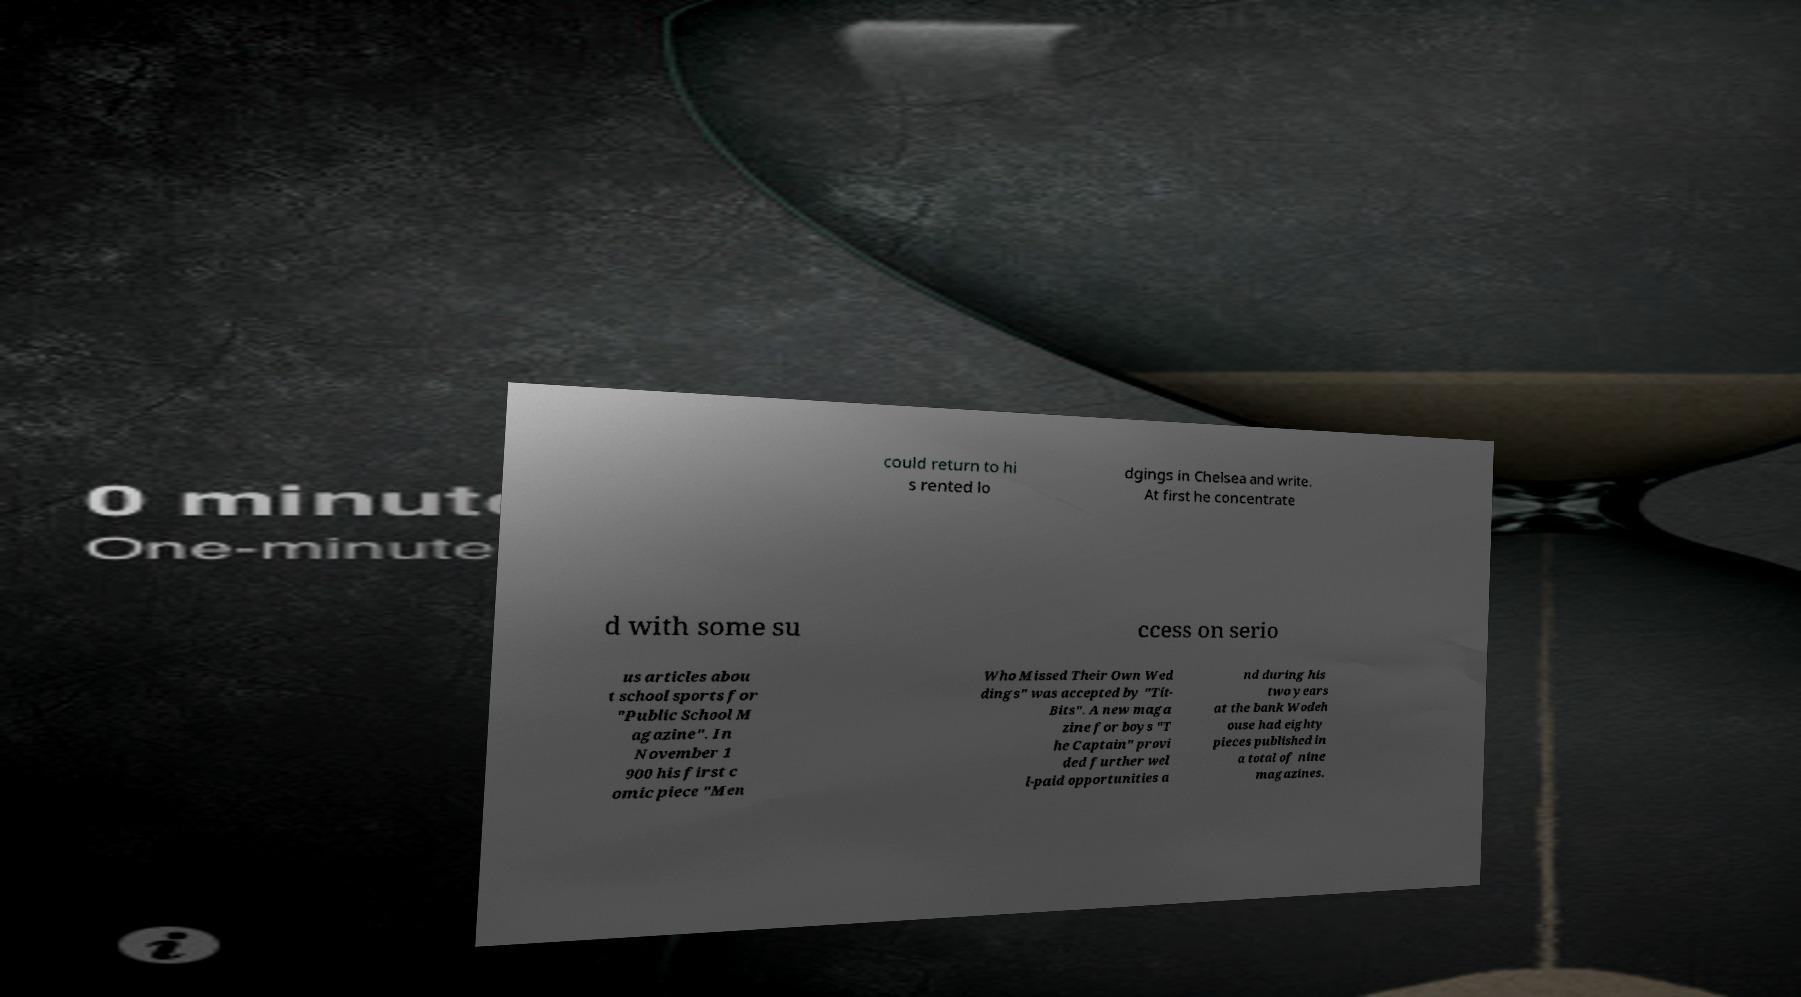What messages or text are displayed in this image? I need them in a readable, typed format. could return to hi s rented lo dgings in Chelsea and write. At first he concentrate d with some su ccess on serio us articles abou t school sports for "Public School M agazine". In November 1 900 his first c omic piece "Men Who Missed Their Own Wed dings" was accepted by "Tit- Bits". A new maga zine for boys "T he Captain" provi ded further wel l-paid opportunities a nd during his two years at the bank Wodeh ouse had eighty pieces published in a total of nine magazines. 